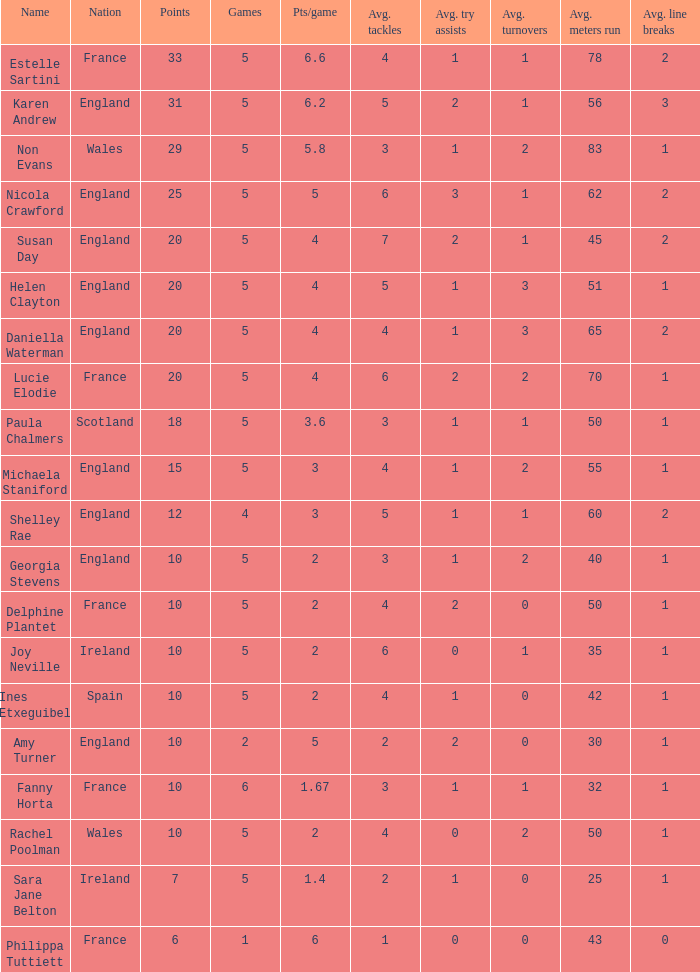Can you tell me the lowest Pts/game that has the Name of philippa tuttiett, and the Points larger then 6? None. 